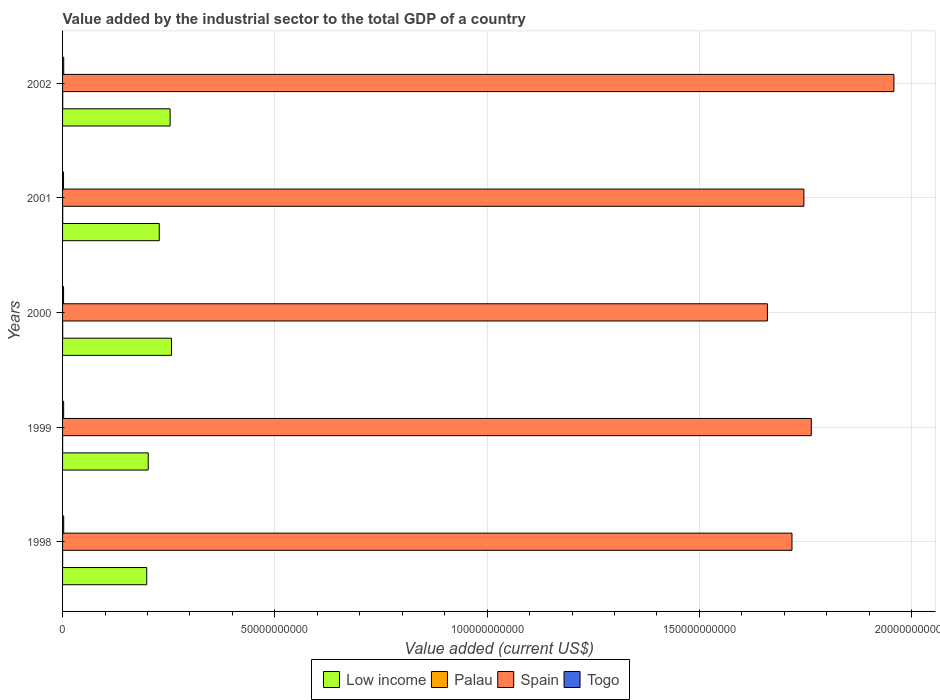How many bars are there on the 2nd tick from the top?
Ensure brevity in your answer.  4. What is the label of the 1st group of bars from the top?
Your answer should be compact. 2002. What is the value added by the industrial sector to the total GDP in Low income in 2000?
Provide a short and direct response. 2.57e+1. Across all years, what is the maximum value added by the industrial sector to the total GDP in Togo?
Your answer should be very brief. 2.71e+08. Across all years, what is the minimum value added by the industrial sector to the total GDP in Togo?
Keep it short and to the point. 2.29e+08. In which year was the value added by the industrial sector to the total GDP in Palau maximum?
Keep it short and to the point. 2002. What is the total value added by the industrial sector to the total GDP in Palau in the graph?
Your answer should be very brief. 1.20e+08. What is the difference between the value added by the industrial sector to the total GDP in Palau in 1999 and that in 2001?
Keep it short and to the point. -1.71e+07. What is the difference between the value added by the industrial sector to the total GDP in Togo in 2000 and the value added by the industrial sector to the total GDP in Spain in 2002?
Offer a very short reply. -1.96e+11. What is the average value added by the industrial sector to the total GDP in Spain per year?
Your answer should be compact. 1.77e+11. In the year 2000, what is the difference between the value added by the industrial sector to the total GDP in Low income and value added by the industrial sector to the total GDP in Togo?
Your answer should be compact. 2.54e+1. In how many years, is the value added by the industrial sector to the total GDP in Low income greater than 190000000000 US$?
Your answer should be very brief. 0. What is the ratio of the value added by the industrial sector to the total GDP in Low income in 1999 to that in 2002?
Make the answer very short. 0.8. Is the value added by the industrial sector to the total GDP in Spain in 1998 less than that in 2000?
Your answer should be compact. No. What is the difference between the highest and the second highest value added by the industrial sector to the total GDP in Togo?
Provide a short and direct response. 3.58e+06. What is the difference between the highest and the lowest value added by the industrial sector to the total GDP in Low income?
Offer a terse response. 5.83e+09. Is the sum of the value added by the industrial sector to the total GDP in Togo in 2000 and 2001 greater than the maximum value added by the industrial sector to the total GDP in Palau across all years?
Offer a very short reply. Yes. Is it the case that in every year, the sum of the value added by the industrial sector to the total GDP in Low income and value added by the industrial sector to the total GDP in Spain is greater than the sum of value added by the industrial sector to the total GDP in Togo and value added by the industrial sector to the total GDP in Palau?
Make the answer very short. Yes. What does the 2nd bar from the bottom in 2000 represents?
Offer a terse response. Palau. How many bars are there?
Keep it short and to the point. 20. How many years are there in the graph?
Offer a terse response. 5. Are the values on the major ticks of X-axis written in scientific E-notation?
Offer a very short reply. No. What is the title of the graph?
Your answer should be very brief. Value added by the industrial sector to the total GDP of a country. What is the label or title of the X-axis?
Your answer should be very brief. Value added (current US$). What is the Value added (current US$) in Low income in 1998?
Provide a short and direct response. 1.98e+1. What is the Value added (current US$) of Palau in 1998?
Your response must be concise. 1.46e+07. What is the Value added (current US$) of Spain in 1998?
Provide a succinct answer. 1.72e+11. What is the Value added (current US$) of Togo in 1998?
Keep it short and to the point. 2.68e+08. What is the Value added (current US$) in Low income in 1999?
Offer a terse response. 2.02e+1. What is the Value added (current US$) of Palau in 1999?
Offer a terse response. 1.35e+07. What is the Value added (current US$) in Spain in 1999?
Offer a very short reply. 1.76e+11. What is the Value added (current US$) in Togo in 1999?
Ensure brevity in your answer.  2.55e+08. What is the Value added (current US$) in Low income in 2000?
Give a very brief answer. 2.57e+1. What is the Value added (current US$) of Palau in 2000?
Make the answer very short. 2.40e+07. What is the Value added (current US$) of Spain in 2000?
Provide a short and direct response. 1.66e+11. What is the Value added (current US$) of Togo in 2000?
Make the answer very short. 2.37e+08. What is the Value added (current US$) in Low income in 2001?
Provide a succinct answer. 2.28e+1. What is the Value added (current US$) of Palau in 2001?
Give a very brief answer. 3.06e+07. What is the Value added (current US$) in Spain in 2001?
Give a very brief answer. 1.75e+11. What is the Value added (current US$) in Togo in 2001?
Ensure brevity in your answer.  2.29e+08. What is the Value added (current US$) in Low income in 2002?
Ensure brevity in your answer.  2.53e+1. What is the Value added (current US$) of Palau in 2002?
Offer a terse response. 3.75e+07. What is the Value added (current US$) of Spain in 2002?
Your answer should be compact. 1.96e+11. What is the Value added (current US$) of Togo in 2002?
Offer a terse response. 2.71e+08. Across all years, what is the maximum Value added (current US$) of Low income?
Make the answer very short. 2.57e+1. Across all years, what is the maximum Value added (current US$) of Palau?
Make the answer very short. 3.75e+07. Across all years, what is the maximum Value added (current US$) in Spain?
Ensure brevity in your answer.  1.96e+11. Across all years, what is the maximum Value added (current US$) in Togo?
Your response must be concise. 2.71e+08. Across all years, what is the minimum Value added (current US$) of Low income?
Provide a short and direct response. 1.98e+1. Across all years, what is the minimum Value added (current US$) in Palau?
Make the answer very short. 1.35e+07. Across all years, what is the minimum Value added (current US$) in Spain?
Make the answer very short. 1.66e+11. Across all years, what is the minimum Value added (current US$) of Togo?
Keep it short and to the point. 2.29e+08. What is the total Value added (current US$) of Low income in the graph?
Provide a succinct answer. 1.14e+11. What is the total Value added (current US$) in Palau in the graph?
Make the answer very short. 1.20e+08. What is the total Value added (current US$) in Spain in the graph?
Offer a very short reply. 8.85e+11. What is the total Value added (current US$) of Togo in the graph?
Keep it short and to the point. 1.26e+09. What is the difference between the Value added (current US$) in Low income in 1998 and that in 1999?
Keep it short and to the point. -3.53e+08. What is the difference between the Value added (current US$) in Palau in 1998 and that in 1999?
Ensure brevity in your answer.  1.16e+06. What is the difference between the Value added (current US$) in Spain in 1998 and that in 1999?
Ensure brevity in your answer.  -4.55e+09. What is the difference between the Value added (current US$) in Togo in 1998 and that in 1999?
Your response must be concise. 1.22e+07. What is the difference between the Value added (current US$) of Low income in 1998 and that in 2000?
Give a very brief answer. -5.83e+09. What is the difference between the Value added (current US$) in Palau in 1998 and that in 2000?
Offer a terse response. -9.34e+06. What is the difference between the Value added (current US$) of Spain in 1998 and that in 2000?
Make the answer very short. 5.79e+09. What is the difference between the Value added (current US$) of Togo in 1998 and that in 2000?
Your answer should be compact. 3.06e+07. What is the difference between the Value added (current US$) of Low income in 1998 and that in 2001?
Offer a very short reply. -2.96e+09. What is the difference between the Value added (current US$) of Palau in 1998 and that in 2001?
Your response must be concise. -1.59e+07. What is the difference between the Value added (current US$) in Spain in 1998 and that in 2001?
Keep it short and to the point. -2.81e+09. What is the difference between the Value added (current US$) in Togo in 1998 and that in 2001?
Offer a terse response. 3.91e+07. What is the difference between the Value added (current US$) of Low income in 1998 and that in 2002?
Your answer should be very brief. -5.51e+09. What is the difference between the Value added (current US$) in Palau in 1998 and that in 2002?
Your answer should be compact. -2.29e+07. What is the difference between the Value added (current US$) of Spain in 1998 and that in 2002?
Your answer should be very brief. -2.40e+1. What is the difference between the Value added (current US$) in Togo in 1998 and that in 2002?
Ensure brevity in your answer.  -3.58e+06. What is the difference between the Value added (current US$) in Low income in 1999 and that in 2000?
Give a very brief answer. -5.48e+09. What is the difference between the Value added (current US$) of Palau in 1999 and that in 2000?
Offer a very short reply. -1.05e+07. What is the difference between the Value added (current US$) of Spain in 1999 and that in 2000?
Keep it short and to the point. 1.03e+1. What is the difference between the Value added (current US$) of Togo in 1999 and that in 2000?
Your response must be concise. 1.84e+07. What is the difference between the Value added (current US$) of Low income in 1999 and that in 2001?
Provide a short and direct response. -2.61e+09. What is the difference between the Value added (current US$) in Palau in 1999 and that in 2001?
Offer a terse response. -1.71e+07. What is the difference between the Value added (current US$) of Spain in 1999 and that in 2001?
Your answer should be very brief. 1.74e+09. What is the difference between the Value added (current US$) in Togo in 1999 and that in 2001?
Ensure brevity in your answer.  2.69e+07. What is the difference between the Value added (current US$) in Low income in 1999 and that in 2002?
Ensure brevity in your answer.  -5.16e+09. What is the difference between the Value added (current US$) in Palau in 1999 and that in 2002?
Offer a terse response. -2.41e+07. What is the difference between the Value added (current US$) in Spain in 1999 and that in 2002?
Give a very brief answer. -1.95e+1. What is the difference between the Value added (current US$) in Togo in 1999 and that in 2002?
Keep it short and to the point. -1.57e+07. What is the difference between the Value added (current US$) in Low income in 2000 and that in 2001?
Your response must be concise. 2.87e+09. What is the difference between the Value added (current US$) of Palau in 2000 and that in 2001?
Keep it short and to the point. -6.59e+06. What is the difference between the Value added (current US$) of Spain in 2000 and that in 2001?
Provide a short and direct response. -8.60e+09. What is the difference between the Value added (current US$) in Togo in 2000 and that in 2001?
Keep it short and to the point. 8.55e+06. What is the difference between the Value added (current US$) of Low income in 2000 and that in 2002?
Your answer should be very brief. 3.21e+08. What is the difference between the Value added (current US$) in Palau in 2000 and that in 2002?
Offer a very short reply. -1.36e+07. What is the difference between the Value added (current US$) of Spain in 2000 and that in 2002?
Provide a succinct answer. -2.98e+1. What is the difference between the Value added (current US$) of Togo in 2000 and that in 2002?
Offer a very short reply. -3.41e+07. What is the difference between the Value added (current US$) in Low income in 2001 and that in 2002?
Offer a very short reply. -2.55e+09. What is the difference between the Value added (current US$) of Palau in 2001 and that in 2002?
Offer a very short reply. -6.97e+06. What is the difference between the Value added (current US$) in Spain in 2001 and that in 2002?
Provide a succinct answer. -2.12e+1. What is the difference between the Value added (current US$) in Togo in 2001 and that in 2002?
Ensure brevity in your answer.  -4.27e+07. What is the difference between the Value added (current US$) in Low income in 1998 and the Value added (current US$) in Palau in 1999?
Your answer should be compact. 1.98e+1. What is the difference between the Value added (current US$) in Low income in 1998 and the Value added (current US$) in Spain in 1999?
Offer a terse response. -1.57e+11. What is the difference between the Value added (current US$) in Low income in 1998 and the Value added (current US$) in Togo in 1999?
Ensure brevity in your answer.  1.96e+1. What is the difference between the Value added (current US$) in Palau in 1998 and the Value added (current US$) in Spain in 1999?
Offer a very short reply. -1.76e+11. What is the difference between the Value added (current US$) in Palau in 1998 and the Value added (current US$) in Togo in 1999?
Your answer should be very brief. -2.41e+08. What is the difference between the Value added (current US$) in Spain in 1998 and the Value added (current US$) in Togo in 1999?
Make the answer very short. 1.72e+11. What is the difference between the Value added (current US$) of Low income in 1998 and the Value added (current US$) of Palau in 2000?
Your answer should be compact. 1.98e+1. What is the difference between the Value added (current US$) in Low income in 1998 and the Value added (current US$) in Spain in 2000?
Give a very brief answer. -1.46e+11. What is the difference between the Value added (current US$) in Low income in 1998 and the Value added (current US$) in Togo in 2000?
Offer a very short reply. 1.96e+1. What is the difference between the Value added (current US$) of Palau in 1998 and the Value added (current US$) of Spain in 2000?
Your answer should be very brief. -1.66e+11. What is the difference between the Value added (current US$) in Palau in 1998 and the Value added (current US$) in Togo in 2000?
Your answer should be very brief. -2.22e+08. What is the difference between the Value added (current US$) in Spain in 1998 and the Value added (current US$) in Togo in 2000?
Keep it short and to the point. 1.72e+11. What is the difference between the Value added (current US$) of Low income in 1998 and the Value added (current US$) of Palau in 2001?
Make the answer very short. 1.98e+1. What is the difference between the Value added (current US$) of Low income in 1998 and the Value added (current US$) of Spain in 2001?
Give a very brief answer. -1.55e+11. What is the difference between the Value added (current US$) in Low income in 1998 and the Value added (current US$) in Togo in 2001?
Make the answer very short. 1.96e+1. What is the difference between the Value added (current US$) of Palau in 1998 and the Value added (current US$) of Spain in 2001?
Your response must be concise. -1.75e+11. What is the difference between the Value added (current US$) of Palau in 1998 and the Value added (current US$) of Togo in 2001?
Offer a terse response. -2.14e+08. What is the difference between the Value added (current US$) of Spain in 1998 and the Value added (current US$) of Togo in 2001?
Offer a very short reply. 1.72e+11. What is the difference between the Value added (current US$) of Low income in 1998 and the Value added (current US$) of Palau in 2002?
Your response must be concise. 1.98e+1. What is the difference between the Value added (current US$) of Low income in 1998 and the Value added (current US$) of Spain in 2002?
Provide a succinct answer. -1.76e+11. What is the difference between the Value added (current US$) of Low income in 1998 and the Value added (current US$) of Togo in 2002?
Your response must be concise. 1.96e+1. What is the difference between the Value added (current US$) in Palau in 1998 and the Value added (current US$) in Spain in 2002?
Your response must be concise. -1.96e+11. What is the difference between the Value added (current US$) in Palau in 1998 and the Value added (current US$) in Togo in 2002?
Give a very brief answer. -2.57e+08. What is the difference between the Value added (current US$) in Spain in 1998 and the Value added (current US$) in Togo in 2002?
Offer a terse response. 1.72e+11. What is the difference between the Value added (current US$) in Low income in 1999 and the Value added (current US$) in Palau in 2000?
Offer a terse response. 2.02e+1. What is the difference between the Value added (current US$) of Low income in 1999 and the Value added (current US$) of Spain in 2000?
Offer a very short reply. -1.46e+11. What is the difference between the Value added (current US$) in Low income in 1999 and the Value added (current US$) in Togo in 2000?
Offer a terse response. 1.99e+1. What is the difference between the Value added (current US$) in Palau in 1999 and the Value added (current US$) in Spain in 2000?
Keep it short and to the point. -1.66e+11. What is the difference between the Value added (current US$) in Palau in 1999 and the Value added (current US$) in Togo in 2000?
Offer a very short reply. -2.24e+08. What is the difference between the Value added (current US$) in Spain in 1999 and the Value added (current US$) in Togo in 2000?
Keep it short and to the point. 1.76e+11. What is the difference between the Value added (current US$) of Low income in 1999 and the Value added (current US$) of Palau in 2001?
Offer a terse response. 2.01e+1. What is the difference between the Value added (current US$) of Low income in 1999 and the Value added (current US$) of Spain in 2001?
Your answer should be compact. -1.54e+11. What is the difference between the Value added (current US$) in Low income in 1999 and the Value added (current US$) in Togo in 2001?
Your answer should be very brief. 1.99e+1. What is the difference between the Value added (current US$) in Palau in 1999 and the Value added (current US$) in Spain in 2001?
Give a very brief answer. -1.75e+11. What is the difference between the Value added (current US$) in Palau in 1999 and the Value added (current US$) in Togo in 2001?
Give a very brief answer. -2.15e+08. What is the difference between the Value added (current US$) in Spain in 1999 and the Value added (current US$) in Togo in 2001?
Your answer should be compact. 1.76e+11. What is the difference between the Value added (current US$) of Low income in 1999 and the Value added (current US$) of Palau in 2002?
Your answer should be very brief. 2.01e+1. What is the difference between the Value added (current US$) in Low income in 1999 and the Value added (current US$) in Spain in 2002?
Provide a short and direct response. -1.76e+11. What is the difference between the Value added (current US$) in Low income in 1999 and the Value added (current US$) in Togo in 2002?
Give a very brief answer. 1.99e+1. What is the difference between the Value added (current US$) in Palau in 1999 and the Value added (current US$) in Spain in 2002?
Provide a short and direct response. -1.96e+11. What is the difference between the Value added (current US$) of Palau in 1999 and the Value added (current US$) of Togo in 2002?
Your answer should be very brief. -2.58e+08. What is the difference between the Value added (current US$) of Spain in 1999 and the Value added (current US$) of Togo in 2002?
Offer a very short reply. 1.76e+11. What is the difference between the Value added (current US$) of Low income in 2000 and the Value added (current US$) of Palau in 2001?
Offer a very short reply. 2.56e+1. What is the difference between the Value added (current US$) of Low income in 2000 and the Value added (current US$) of Spain in 2001?
Your answer should be compact. -1.49e+11. What is the difference between the Value added (current US$) of Low income in 2000 and the Value added (current US$) of Togo in 2001?
Offer a very short reply. 2.54e+1. What is the difference between the Value added (current US$) in Palau in 2000 and the Value added (current US$) in Spain in 2001?
Provide a succinct answer. -1.75e+11. What is the difference between the Value added (current US$) in Palau in 2000 and the Value added (current US$) in Togo in 2001?
Offer a very short reply. -2.05e+08. What is the difference between the Value added (current US$) in Spain in 2000 and the Value added (current US$) in Togo in 2001?
Give a very brief answer. 1.66e+11. What is the difference between the Value added (current US$) in Low income in 2000 and the Value added (current US$) in Palau in 2002?
Your answer should be compact. 2.56e+1. What is the difference between the Value added (current US$) in Low income in 2000 and the Value added (current US$) in Spain in 2002?
Offer a very short reply. -1.70e+11. What is the difference between the Value added (current US$) in Low income in 2000 and the Value added (current US$) in Togo in 2002?
Ensure brevity in your answer.  2.54e+1. What is the difference between the Value added (current US$) in Palau in 2000 and the Value added (current US$) in Spain in 2002?
Provide a short and direct response. -1.96e+11. What is the difference between the Value added (current US$) of Palau in 2000 and the Value added (current US$) of Togo in 2002?
Give a very brief answer. -2.47e+08. What is the difference between the Value added (current US$) of Spain in 2000 and the Value added (current US$) of Togo in 2002?
Offer a very short reply. 1.66e+11. What is the difference between the Value added (current US$) of Low income in 2001 and the Value added (current US$) of Palau in 2002?
Your answer should be compact. 2.27e+1. What is the difference between the Value added (current US$) of Low income in 2001 and the Value added (current US$) of Spain in 2002?
Make the answer very short. -1.73e+11. What is the difference between the Value added (current US$) in Low income in 2001 and the Value added (current US$) in Togo in 2002?
Offer a terse response. 2.25e+1. What is the difference between the Value added (current US$) in Palau in 2001 and the Value added (current US$) in Spain in 2002?
Your answer should be very brief. -1.96e+11. What is the difference between the Value added (current US$) of Palau in 2001 and the Value added (current US$) of Togo in 2002?
Your response must be concise. -2.41e+08. What is the difference between the Value added (current US$) of Spain in 2001 and the Value added (current US$) of Togo in 2002?
Make the answer very short. 1.74e+11. What is the average Value added (current US$) in Low income per year?
Keep it short and to the point. 2.28e+1. What is the average Value added (current US$) of Palau per year?
Provide a short and direct response. 2.40e+07. What is the average Value added (current US$) of Spain per year?
Offer a very short reply. 1.77e+11. What is the average Value added (current US$) in Togo per year?
Offer a terse response. 2.52e+08. In the year 1998, what is the difference between the Value added (current US$) in Low income and Value added (current US$) in Palau?
Offer a very short reply. 1.98e+1. In the year 1998, what is the difference between the Value added (current US$) of Low income and Value added (current US$) of Spain?
Provide a short and direct response. -1.52e+11. In the year 1998, what is the difference between the Value added (current US$) in Low income and Value added (current US$) in Togo?
Ensure brevity in your answer.  1.96e+1. In the year 1998, what is the difference between the Value added (current US$) of Palau and Value added (current US$) of Spain?
Provide a short and direct response. -1.72e+11. In the year 1998, what is the difference between the Value added (current US$) in Palau and Value added (current US$) in Togo?
Offer a terse response. -2.53e+08. In the year 1998, what is the difference between the Value added (current US$) of Spain and Value added (current US$) of Togo?
Your answer should be very brief. 1.72e+11. In the year 1999, what is the difference between the Value added (current US$) of Low income and Value added (current US$) of Palau?
Ensure brevity in your answer.  2.02e+1. In the year 1999, what is the difference between the Value added (current US$) in Low income and Value added (current US$) in Spain?
Your response must be concise. -1.56e+11. In the year 1999, what is the difference between the Value added (current US$) of Low income and Value added (current US$) of Togo?
Offer a terse response. 1.99e+1. In the year 1999, what is the difference between the Value added (current US$) of Palau and Value added (current US$) of Spain?
Give a very brief answer. -1.76e+11. In the year 1999, what is the difference between the Value added (current US$) in Palau and Value added (current US$) in Togo?
Your response must be concise. -2.42e+08. In the year 1999, what is the difference between the Value added (current US$) of Spain and Value added (current US$) of Togo?
Your response must be concise. 1.76e+11. In the year 2000, what is the difference between the Value added (current US$) of Low income and Value added (current US$) of Palau?
Make the answer very short. 2.56e+1. In the year 2000, what is the difference between the Value added (current US$) in Low income and Value added (current US$) in Spain?
Make the answer very short. -1.40e+11. In the year 2000, what is the difference between the Value added (current US$) in Low income and Value added (current US$) in Togo?
Provide a short and direct response. 2.54e+1. In the year 2000, what is the difference between the Value added (current US$) of Palau and Value added (current US$) of Spain?
Your response must be concise. -1.66e+11. In the year 2000, what is the difference between the Value added (current US$) of Palau and Value added (current US$) of Togo?
Your answer should be very brief. -2.13e+08. In the year 2000, what is the difference between the Value added (current US$) in Spain and Value added (current US$) in Togo?
Provide a short and direct response. 1.66e+11. In the year 2001, what is the difference between the Value added (current US$) in Low income and Value added (current US$) in Palau?
Your answer should be compact. 2.28e+1. In the year 2001, what is the difference between the Value added (current US$) of Low income and Value added (current US$) of Spain?
Ensure brevity in your answer.  -1.52e+11. In the year 2001, what is the difference between the Value added (current US$) of Low income and Value added (current US$) of Togo?
Make the answer very short. 2.26e+1. In the year 2001, what is the difference between the Value added (current US$) in Palau and Value added (current US$) in Spain?
Provide a succinct answer. -1.75e+11. In the year 2001, what is the difference between the Value added (current US$) of Palau and Value added (current US$) of Togo?
Your answer should be compact. -1.98e+08. In the year 2001, what is the difference between the Value added (current US$) in Spain and Value added (current US$) in Togo?
Keep it short and to the point. 1.74e+11. In the year 2002, what is the difference between the Value added (current US$) of Low income and Value added (current US$) of Palau?
Make the answer very short. 2.53e+1. In the year 2002, what is the difference between the Value added (current US$) of Low income and Value added (current US$) of Spain?
Offer a terse response. -1.71e+11. In the year 2002, what is the difference between the Value added (current US$) in Low income and Value added (current US$) in Togo?
Offer a very short reply. 2.51e+1. In the year 2002, what is the difference between the Value added (current US$) in Palau and Value added (current US$) in Spain?
Ensure brevity in your answer.  -1.96e+11. In the year 2002, what is the difference between the Value added (current US$) of Palau and Value added (current US$) of Togo?
Provide a short and direct response. -2.34e+08. In the year 2002, what is the difference between the Value added (current US$) in Spain and Value added (current US$) in Togo?
Offer a very short reply. 1.96e+11. What is the ratio of the Value added (current US$) of Low income in 1998 to that in 1999?
Provide a succinct answer. 0.98. What is the ratio of the Value added (current US$) in Palau in 1998 to that in 1999?
Give a very brief answer. 1.09. What is the ratio of the Value added (current US$) of Spain in 1998 to that in 1999?
Provide a succinct answer. 0.97. What is the ratio of the Value added (current US$) of Togo in 1998 to that in 1999?
Provide a succinct answer. 1.05. What is the ratio of the Value added (current US$) in Low income in 1998 to that in 2000?
Provide a succinct answer. 0.77. What is the ratio of the Value added (current US$) in Palau in 1998 to that in 2000?
Provide a succinct answer. 0.61. What is the ratio of the Value added (current US$) in Spain in 1998 to that in 2000?
Give a very brief answer. 1.03. What is the ratio of the Value added (current US$) of Togo in 1998 to that in 2000?
Your answer should be compact. 1.13. What is the ratio of the Value added (current US$) in Low income in 1998 to that in 2001?
Keep it short and to the point. 0.87. What is the ratio of the Value added (current US$) in Palau in 1998 to that in 2001?
Provide a short and direct response. 0.48. What is the ratio of the Value added (current US$) of Spain in 1998 to that in 2001?
Your answer should be compact. 0.98. What is the ratio of the Value added (current US$) in Togo in 1998 to that in 2001?
Keep it short and to the point. 1.17. What is the ratio of the Value added (current US$) of Low income in 1998 to that in 2002?
Give a very brief answer. 0.78. What is the ratio of the Value added (current US$) in Palau in 1998 to that in 2002?
Provide a succinct answer. 0.39. What is the ratio of the Value added (current US$) in Spain in 1998 to that in 2002?
Your answer should be very brief. 0.88. What is the ratio of the Value added (current US$) in Togo in 1998 to that in 2002?
Provide a short and direct response. 0.99. What is the ratio of the Value added (current US$) in Low income in 1999 to that in 2000?
Your answer should be compact. 0.79. What is the ratio of the Value added (current US$) of Palau in 1999 to that in 2000?
Your answer should be very brief. 0.56. What is the ratio of the Value added (current US$) in Spain in 1999 to that in 2000?
Offer a terse response. 1.06. What is the ratio of the Value added (current US$) of Togo in 1999 to that in 2000?
Ensure brevity in your answer.  1.08. What is the ratio of the Value added (current US$) of Low income in 1999 to that in 2001?
Keep it short and to the point. 0.89. What is the ratio of the Value added (current US$) in Palau in 1999 to that in 2001?
Offer a very short reply. 0.44. What is the ratio of the Value added (current US$) of Spain in 1999 to that in 2001?
Your response must be concise. 1.01. What is the ratio of the Value added (current US$) in Togo in 1999 to that in 2001?
Make the answer very short. 1.12. What is the ratio of the Value added (current US$) in Low income in 1999 to that in 2002?
Offer a terse response. 0.8. What is the ratio of the Value added (current US$) in Palau in 1999 to that in 2002?
Keep it short and to the point. 0.36. What is the ratio of the Value added (current US$) of Spain in 1999 to that in 2002?
Offer a terse response. 0.9. What is the ratio of the Value added (current US$) of Togo in 1999 to that in 2002?
Offer a terse response. 0.94. What is the ratio of the Value added (current US$) of Low income in 2000 to that in 2001?
Your response must be concise. 1.13. What is the ratio of the Value added (current US$) of Palau in 2000 to that in 2001?
Your response must be concise. 0.78. What is the ratio of the Value added (current US$) of Spain in 2000 to that in 2001?
Give a very brief answer. 0.95. What is the ratio of the Value added (current US$) of Togo in 2000 to that in 2001?
Your response must be concise. 1.04. What is the ratio of the Value added (current US$) in Low income in 2000 to that in 2002?
Offer a terse response. 1.01. What is the ratio of the Value added (current US$) of Palau in 2000 to that in 2002?
Offer a terse response. 0.64. What is the ratio of the Value added (current US$) of Spain in 2000 to that in 2002?
Your answer should be very brief. 0.85. What is the ratio of the Value added (current US$) of Togo in 2000 to that in 2002?
Offer a very short reply. 0.87. What is the ratio of the Value added (current US$) of Low income in 2001 to that in 2002?
Give a very brief answer. 0.9. What is the ratio of the Value added (current US$) of Palau in 2001 to that in 2002?
Give a very brief answer. 0.81. What is the ratio of the Value added (current US$) in Spain in 2001 to that in 2002?
Provide a succinct answer. 0.89. What is the ratio of the Value added (current US$) of Togo in 2001 to that in 2002?
Give a very brief answer. 0.84. What is the difference between the highest and the second highest Value added (current US$) in Low income?
Ensure brevity in your answer.  3.21e+08. What is the difference between the highest and the second highest Value added (current US$) of Palau?
Your answer should be very brief. 6.97e+06. What is the difference between the highest and the second highest Value added (current US$) of Spain?
Ensure brevity in your answer.  1.95e+1. What is the difference between the highest and the second highest Value added (current US$) in Togo?
Provide a succinct answer. 3.58e+06. What is the difference between the highest and the lowest Value added (current US$) in Low income?
Offer a terse response. 5.83e+09. What is the difference between the highest and the lowest Value added (current US$) of Palau?
Make the answer very short. 2.41e+07. What is the difference between the highest and the lowest Value added (current US$) of Spain?
Your response must be concise. 2.98e+1. What is the difference between the highest and the lowest Value added (current US$) in Togo?
Ensure brevity in your answer.  4.27e+07. 